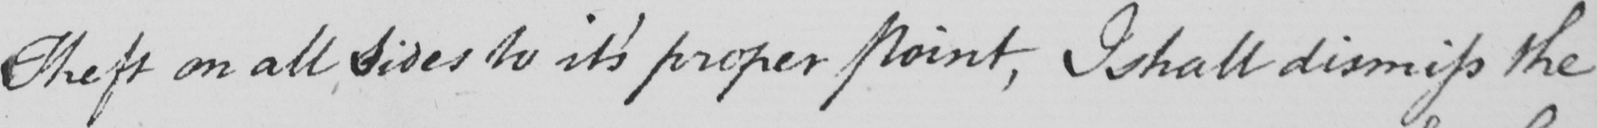What text is written in this handwritten line? Theft on all sides to it ' s proper Point , I shall dismiss the 